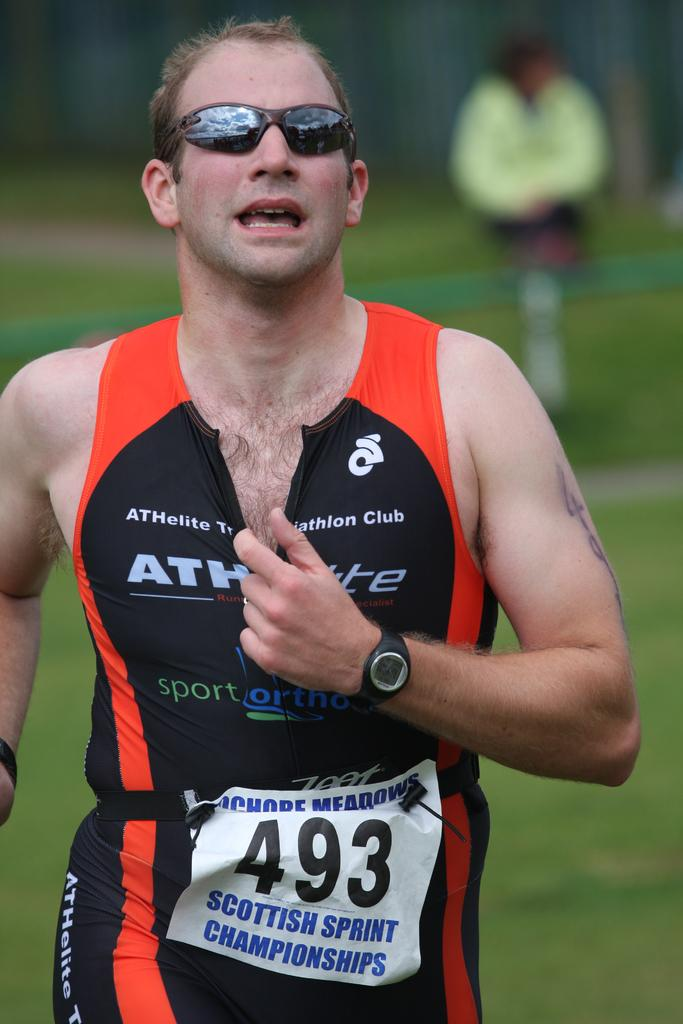<image>
Write a terse but informative summary of the picture. A runner in the Scottish Sprint Championships moves along a grassy area. 